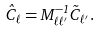Convert formula to latex. <formula><loc_0><loc_0><loc_500><loc_500>\hat { C } _ { \ell } = M ^ { - 1 } _ { \ell \ell ^ { \prime } } \tilde { C } _ { \ell ^ { \prime } } .</formula> 